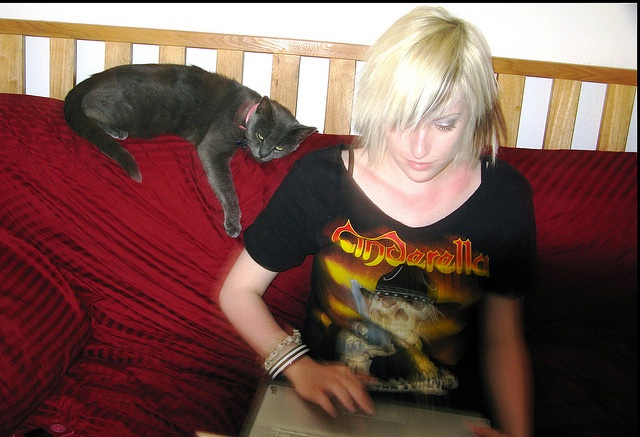Describe the objects in this image and their specific colors. I can see couch in black, maroon, brown, and gray tones, people in black, lightgray, and maroon tones, cat in black, gray, and maroon tones, and laptop in black and gray tones in this image. 